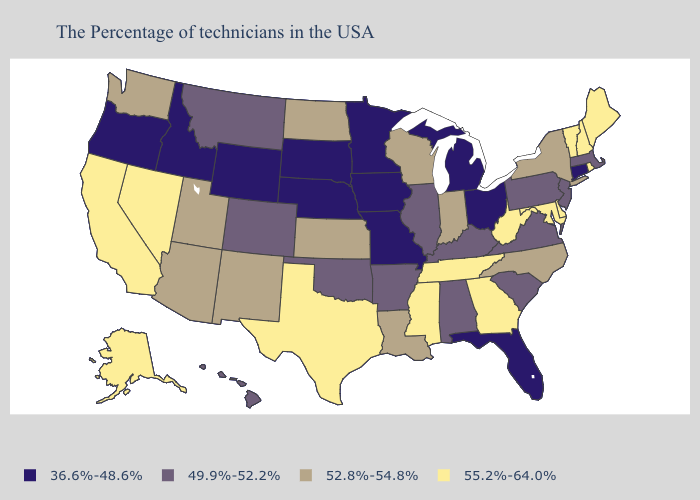Does Illinois have the same value as Alaska?
Keep it brief. No. Name the states that have a value in the range 52.8%-54.8%?
Be succinct. New York, North Carolina, Indiana, Wisconsin, Louisiana, Kansas, North Dakota, New Mexico, Utah, Arizona, Washington. Which states have the lowest value in the USA?
Short answer required. Connecticut, Ohio, Florida, Michigan, Missouri, Minnesota, Iowa, Nebraska, South Dakota, Wyoming, Idaho, Oregon. What is the value of Alaska?
Concise answer only. 55.2%-64.0%. Does the first symbol in the legend represent the smallest category?
Keep it brief. Yes. What is the value of Pennsylvania?
Concise answer only. 49.9%-52.2%. What is the value of Wyoming?
Short answer required. 36.6%-48.6%. What is the value of South Carolina?
Concise answer only. 49.9%-52.2%. Name the states that have a value in the range 52.8%-54.8%?
Be succinct. New York, North Carolina, Indiana, Wisconsin, Louisiana, Kansas, North Dakota, New Mexico, Utah, Arizona, Washington. Name the states that have a value in the range 36.6%-48.6%?
Be succinct. Connecticut, Ohio, Florida, Michigan, Missouri, Minnesota, Iowa, Nebraska, South Dakota, Wyoming, Idaho, Oregon. Name the states that have a value in the range 36.6%-48.6%?
Short answer required. Connecticut, Ohio, Florida, Michigan, Missouri, Minnesota, Iowa, Nebraska, South Dakota, Wyoming, Idaho, Oregon. What is the lowest value in the MidWest?
Write a very short answer. 36.6%-48.6%. Name the states that have a value in the range 55.2%-64.0%?
Quick response, please. Maine, Rhode Island, New Hampshire, Vermont, Delaware, Maryland, West Virginia, Georgia, Tennessee, Mississippi, Texas, Nevada, California, Alaska. Name the states that have a value in the range 36.6%-48.6%?
Be succinct. Connecticut, Ohio, Florida, Michigan, Missouri, Minnesota, Iowa, Nebraska, South Dakota, Wyoming, Idaho, Oregon. Name the states that have a value in the range 49.9%-52.2%?
Short answer required. Massachusetts, New Jersey, Pennsylvania, Virginia, South Carolina, Kentucky, Alabama, Illinois, Arkansas, Oklahoma, Colorado, Montana, Hawaii. 